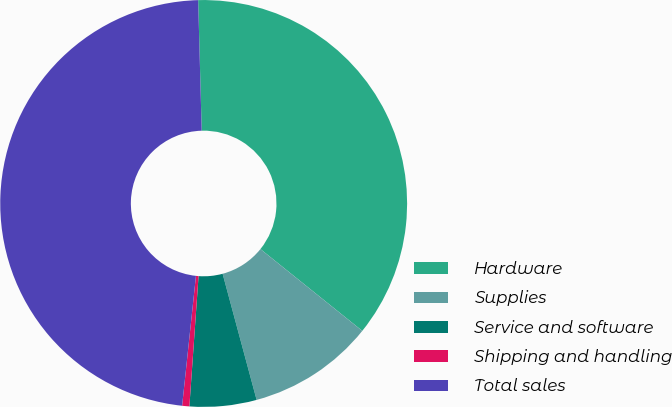Convert chart. <chart><loc_0><loc_0><loc_500><loc_500><pie_chart><fcel>Hardware<fcel>Supplies<fcel>Service and software<fcel>Shipping and handling<fcel>Total sales<nl><fcel>36.2%<fcel>10.04%<fcel>5.31%<fcel>0.57%<fcel>47.88%<nl></chart> 